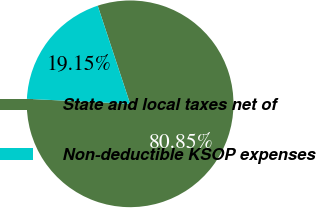Convert chart. <chart><loc_0><loc_0><loc_500><loc_500><pie_chart><fcel>State and local taxes net of<fcel>Non-deductible KSOP expenses<nl><fcel>80.85%<fcel>19.15%<nl></chart> 